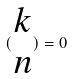<formula> <loc_0><loc_0><loc_500><loc_500>( \begin{matrix} k \\ n \end{matrix} ) = 0</formula> 